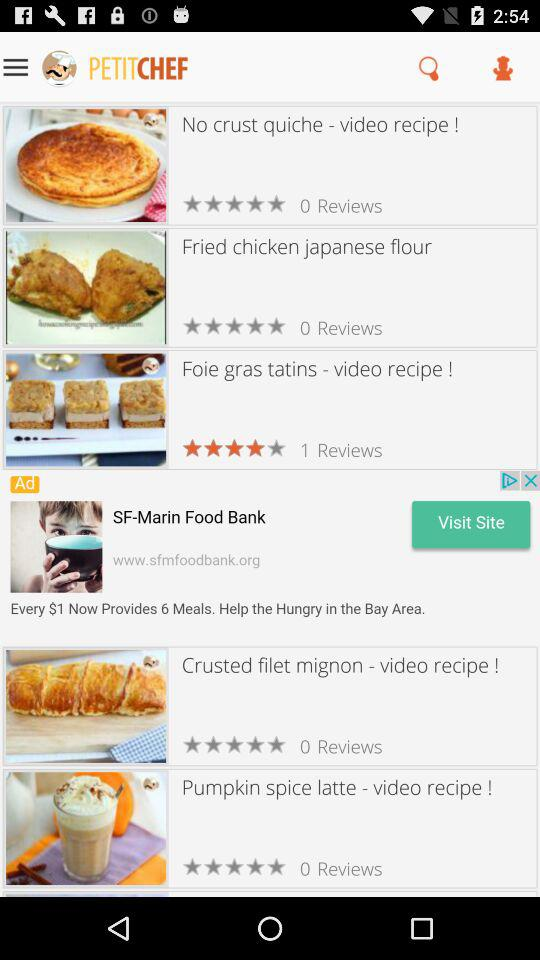What is the number of reviews for the "Foie gras tatins"? The number is 1. 